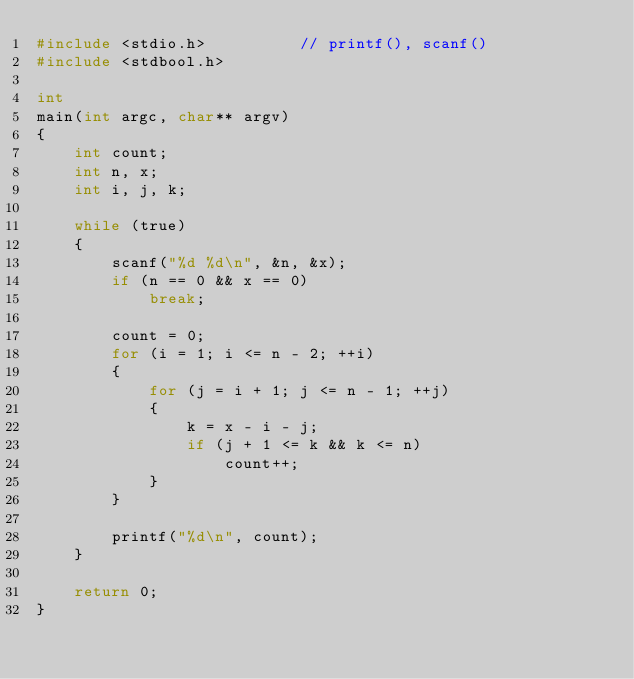Convert code to text. <code><loc_0><loc_0><loc_500><loc_500><_C_>#include <stdio.h>          // printf(), scanf()
#include <stdbool.h>

int
main(int argc, char** argv)
{
	int count;
	int n, x;
	int i, j, k;

	while (true)
	{
		scanf("%d %d\n", &n, &x);
		if (n == 0 && x == 0)
			break;

		count = 0;
		for (i = 1; i <= n - 2; ++i)
		{
			for (j = i + 1; j <= n - 1; ++j)
			{
				k = x - i - j;
				if (j + 1 <= k && k <= n)
					count++;
			}
		}

		printf("%d\n", count);
	}

	return 0;
}</code> 